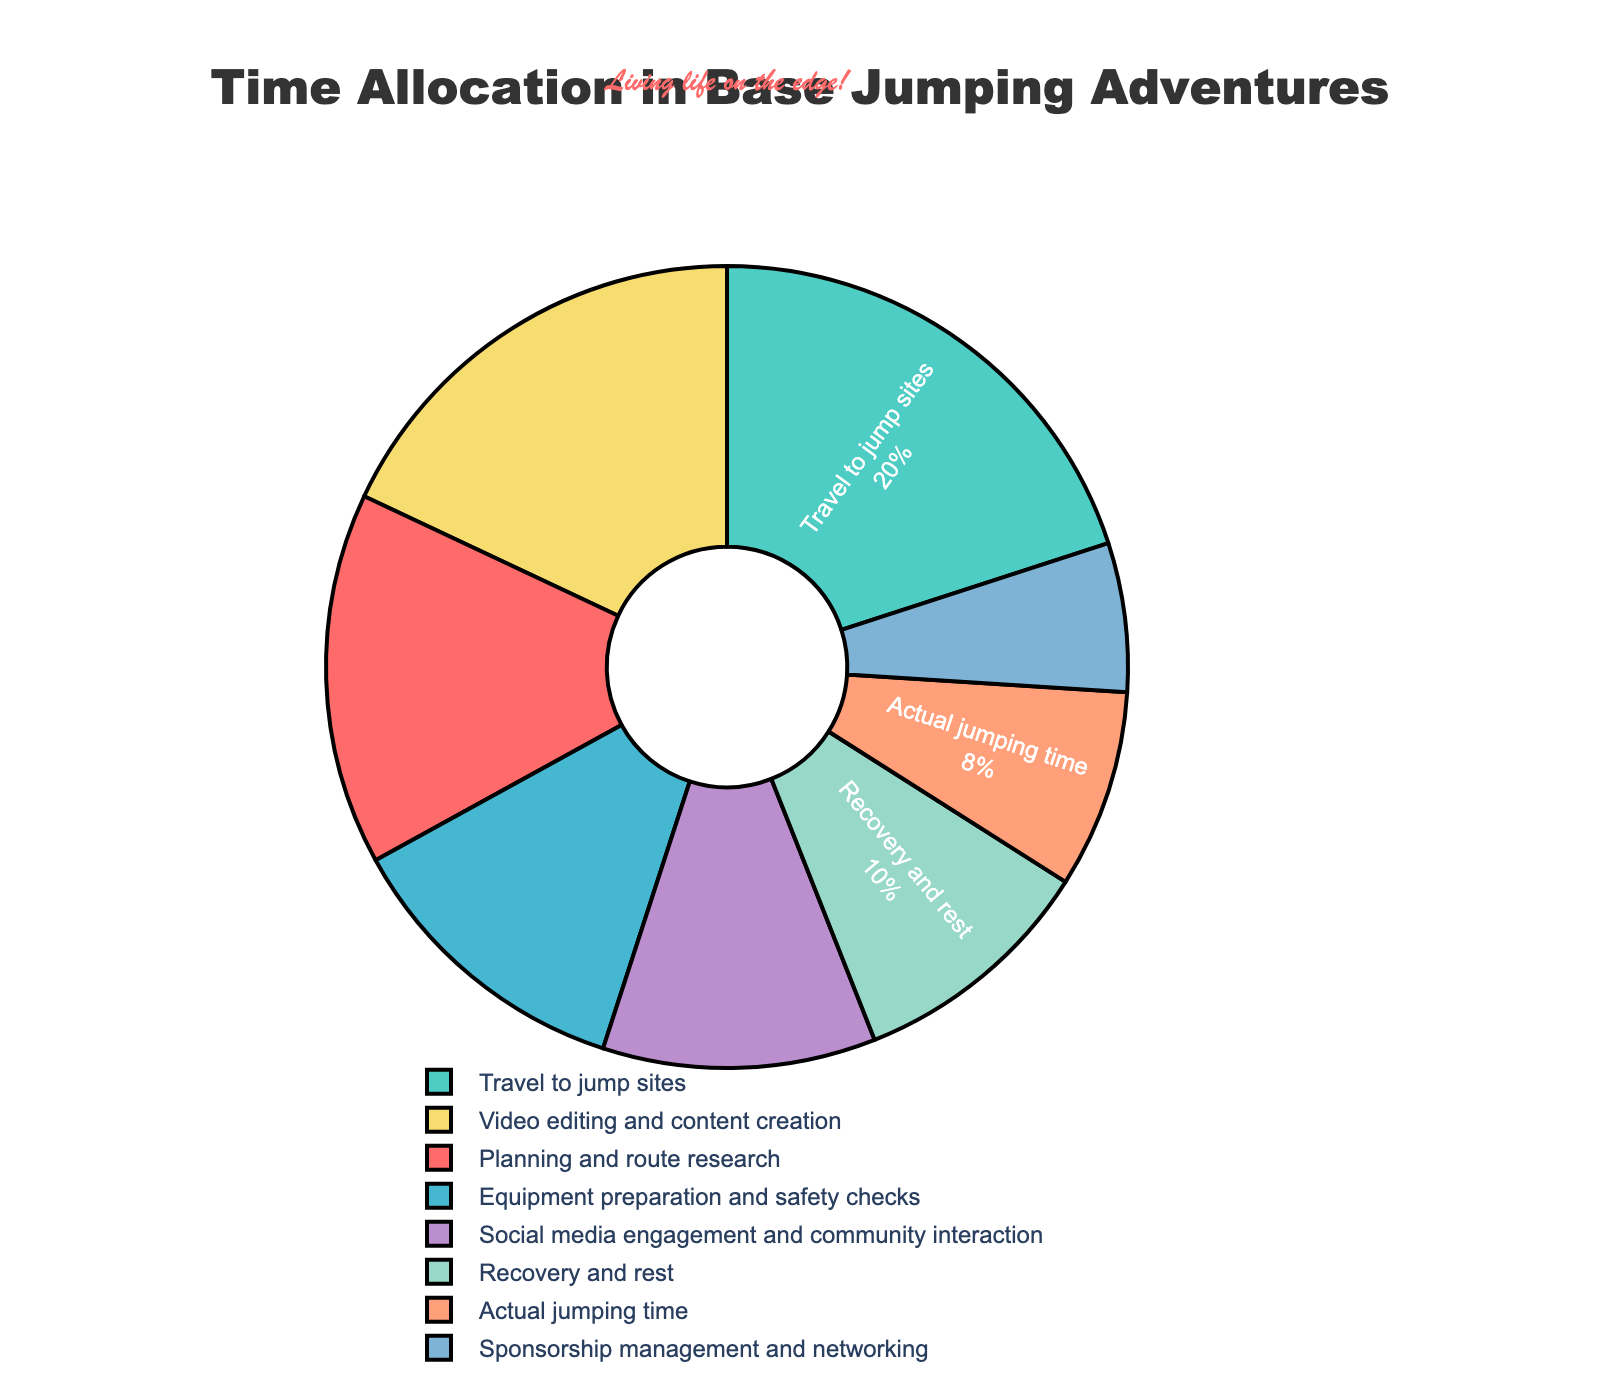What percentage of time is spent on actual jumping? Locate the segment labeled "Actual jumping time" and refer to the percentage value next to it.
Answer: 8% Which two activities combined take up the largest percentage of time? Identify the two segments with the highest percentage values and sum them up. The two largest segments are "Travel to jump sites" at 20% and "Video editing and content creation" at 18%, totaling 38%.
Answer: Travel to jump sites and Video editing and content creation Are more hours spent on planning and route research or social media engagement and community interaction? Compare the percentages of "Planning and route research" (15%) and "Social media engagement and community interaction" (11%).
Answer: Planning and route research What activities together make up less than 20% of the total time? Identify segments whose combined percentage is less than 20%. "Sponsorship management and networking" is 6%, "Actual jumping time" is 8%, and "Recovery and rest" is 10%. Sponsorship management and networking and Actual jumping time combined are 14%.
Answer: Sponsorship management and networking and Actual jumping time Which activity uses the least amount of time? Find the segment with the smallest percentage value, which is "Sponsorship management and networking" at 6%.
Answer: Sponsorship management and networking How much more time is allocated to travel than to recovery? Subtract the percentage of "Recovery and rest" (10%) from "Travel to jump sites" (20%).
Answer: 10% What is the combined percentage of time spent on content creation and social media engagement? Add the percentages of "Video editing and content creation" (18%) and "Social media engagement and community interaction" (11%).
Answer: 29% Is the time spent on planning more than twice the time spent on equipment preparation? Compare "Planning and route research" (15%) to twice the percentage of "Equipment preparation and safety checks" (2 x 12% = 24%).
Answer: No What is the largest visual segment’s percentage and associated activity? Identify the largest segment visually and read the associated label and percentage. The largest segment is "Travel to jump sites" at 20%.
Answer: Travel to jump sites, 20% Rank the activities from most time-consuming to least time-consuming. Order the segments by their percentages from largest to smallest: "Travel to jump sites" (20%), "Video editing and content creation" (18%), "Planning and route research" (15%), "Social media engagement and community interaction" (11%), "Equipment preparation and safety checks" (12%), "Recovery and rest" (10%), "Actual jumping time" (8%), "Sponsorship management and networking" (6%).
Answer: Travel to jump sites, Video editing and content creation, Planning and route research, Equipment preparation and safety checks, Social media engagement and community interaction, Recovery and rest, Actual jumping time, Sponsorship management and networking 